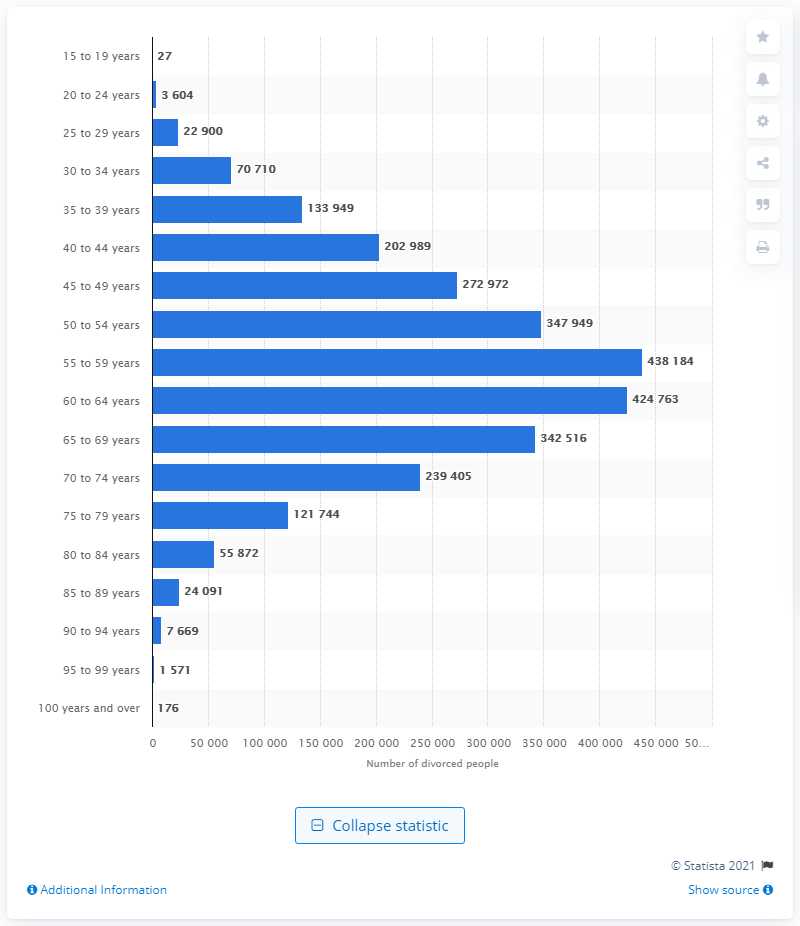Give some essential details in this illustration. In 2020, it is estimated that approximately 27,000 individuals in Canada between the ages of 15 and 19 had gone through a divorce. 